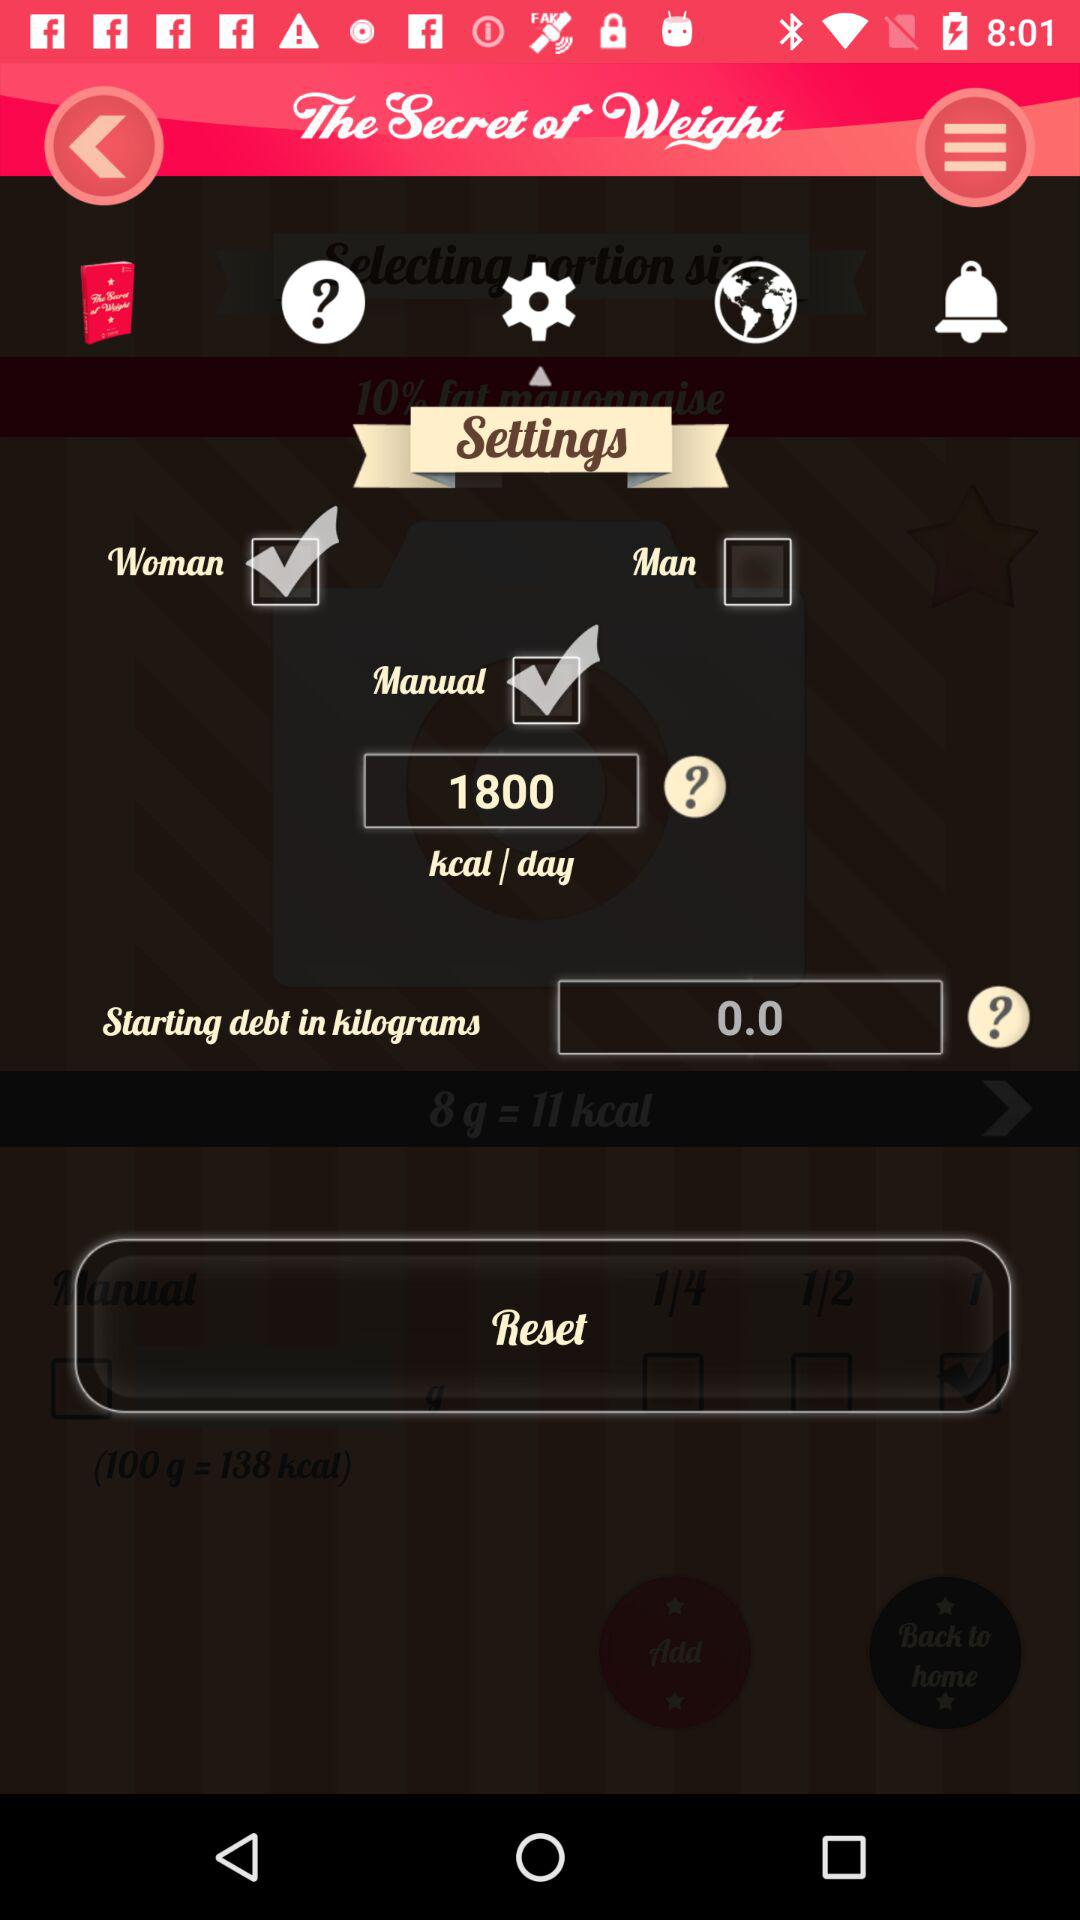How many kcal/day is the user setting?
Answer the question using a single word or phrase. 1800 